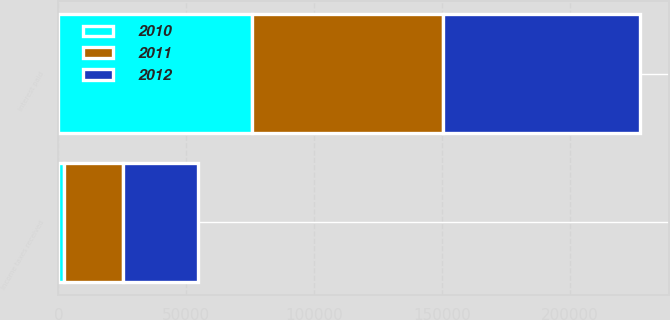Convert chart. <chart><loc_0><loc_0><loc_500><loc_500><stacked_bar_chart><ecel><fcel>Interest paid<fcel>Income taxes received<nl><fcel>2012<fcel>76833<fcel>29251<nl><fcel>2011<fcel>74569<fcel>22893<nl><fcel>2010<fcel>75909<fcel>2379<nl></chart> 